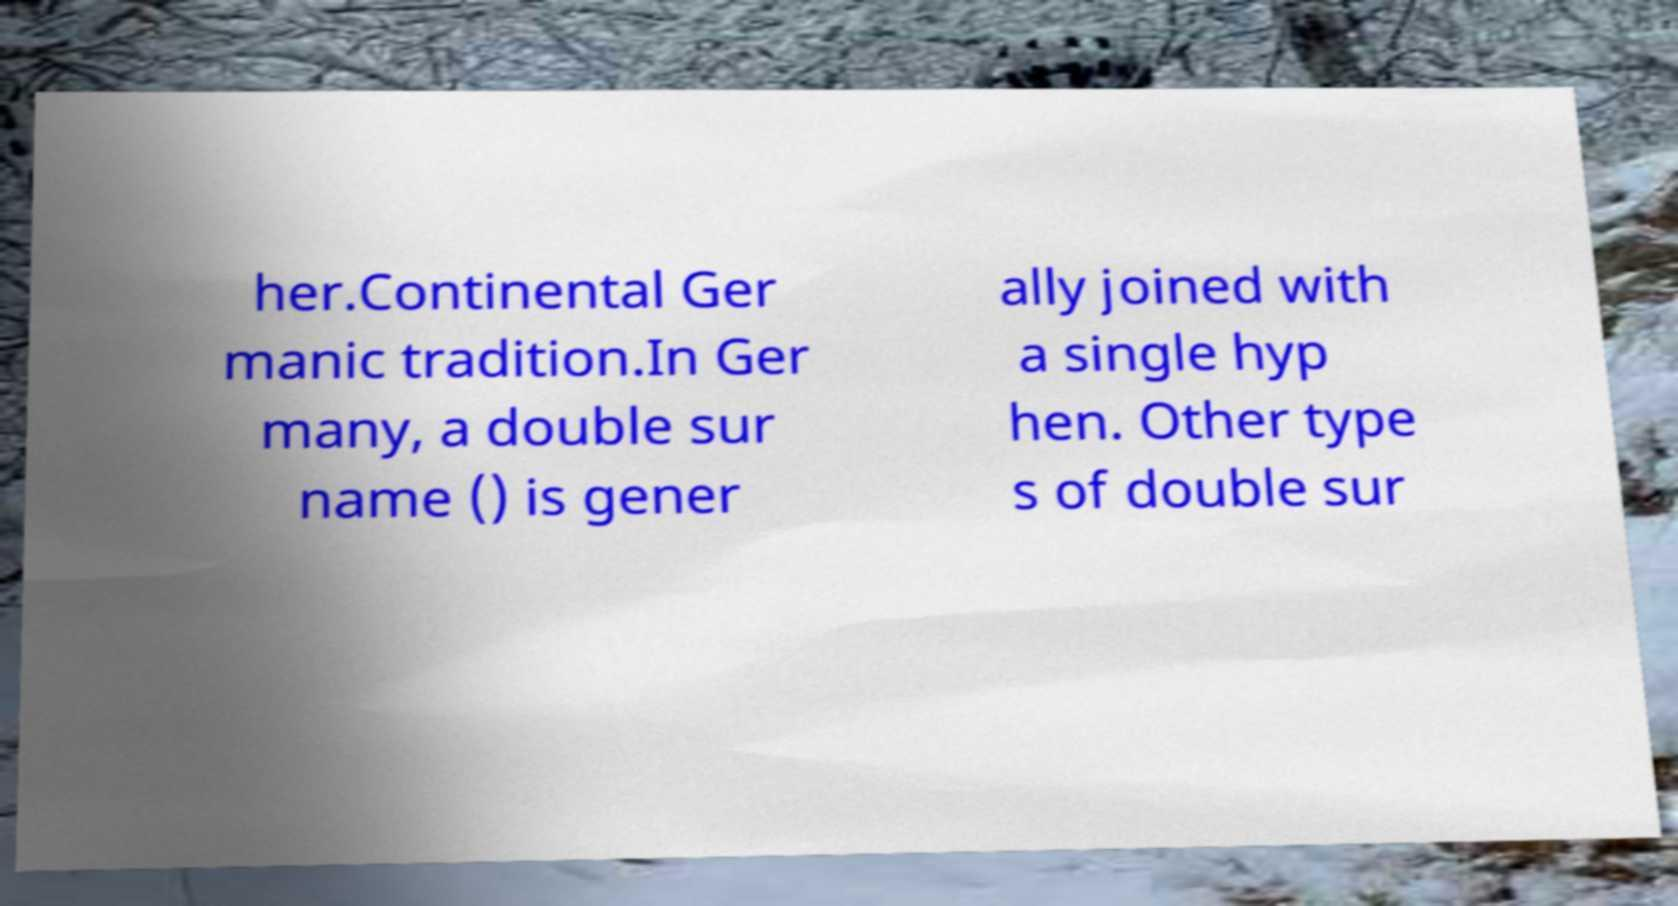There's text embedded in this image that I need extracted. Can you transcribe it verbatim? her.Continental Ger manic tradition.In Ger many, a double sur name () is gener ally joined with a single hyp hen. Other type s of double sur 